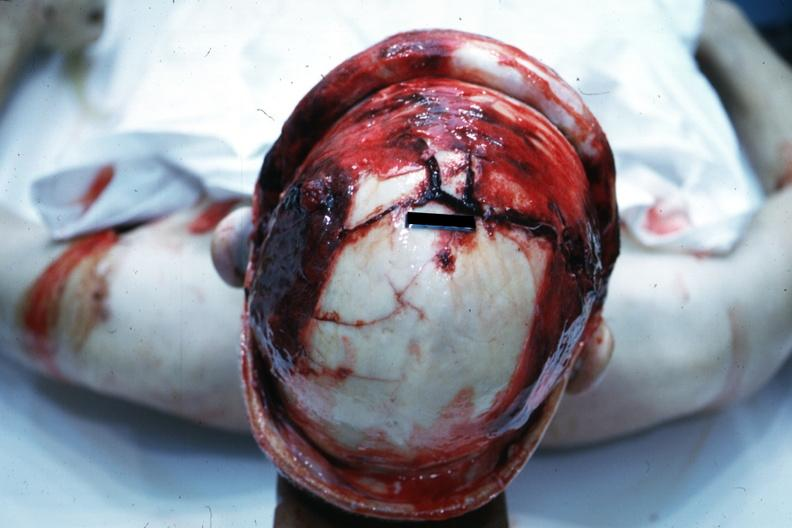s muscle atrophy present?
Answer the question using a single word or phrase. No 